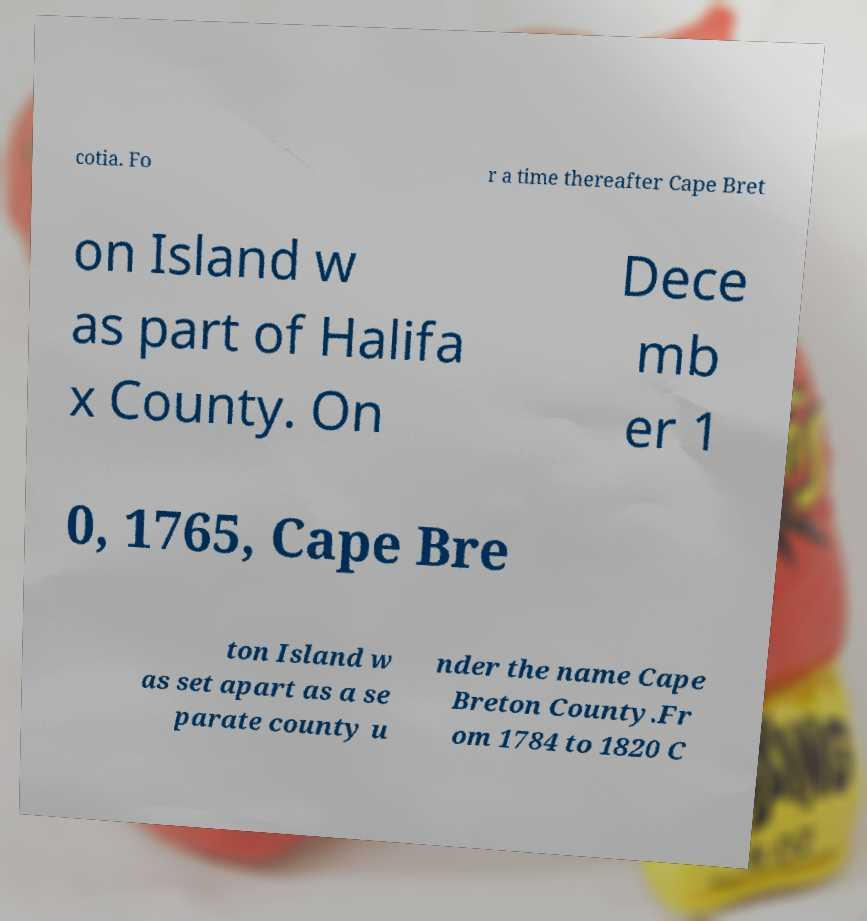Please read and relay the text visible in this image. What does it say? cotia. Fo r a time thereafter Cape Bret on Island w as part of Halifa x County. On Dece mb er 1 0, 1765, Cape Bre ton Island w as set apart as a se parate county u nder the name Cape Breton County.Fr om 1784 to 1820 C 